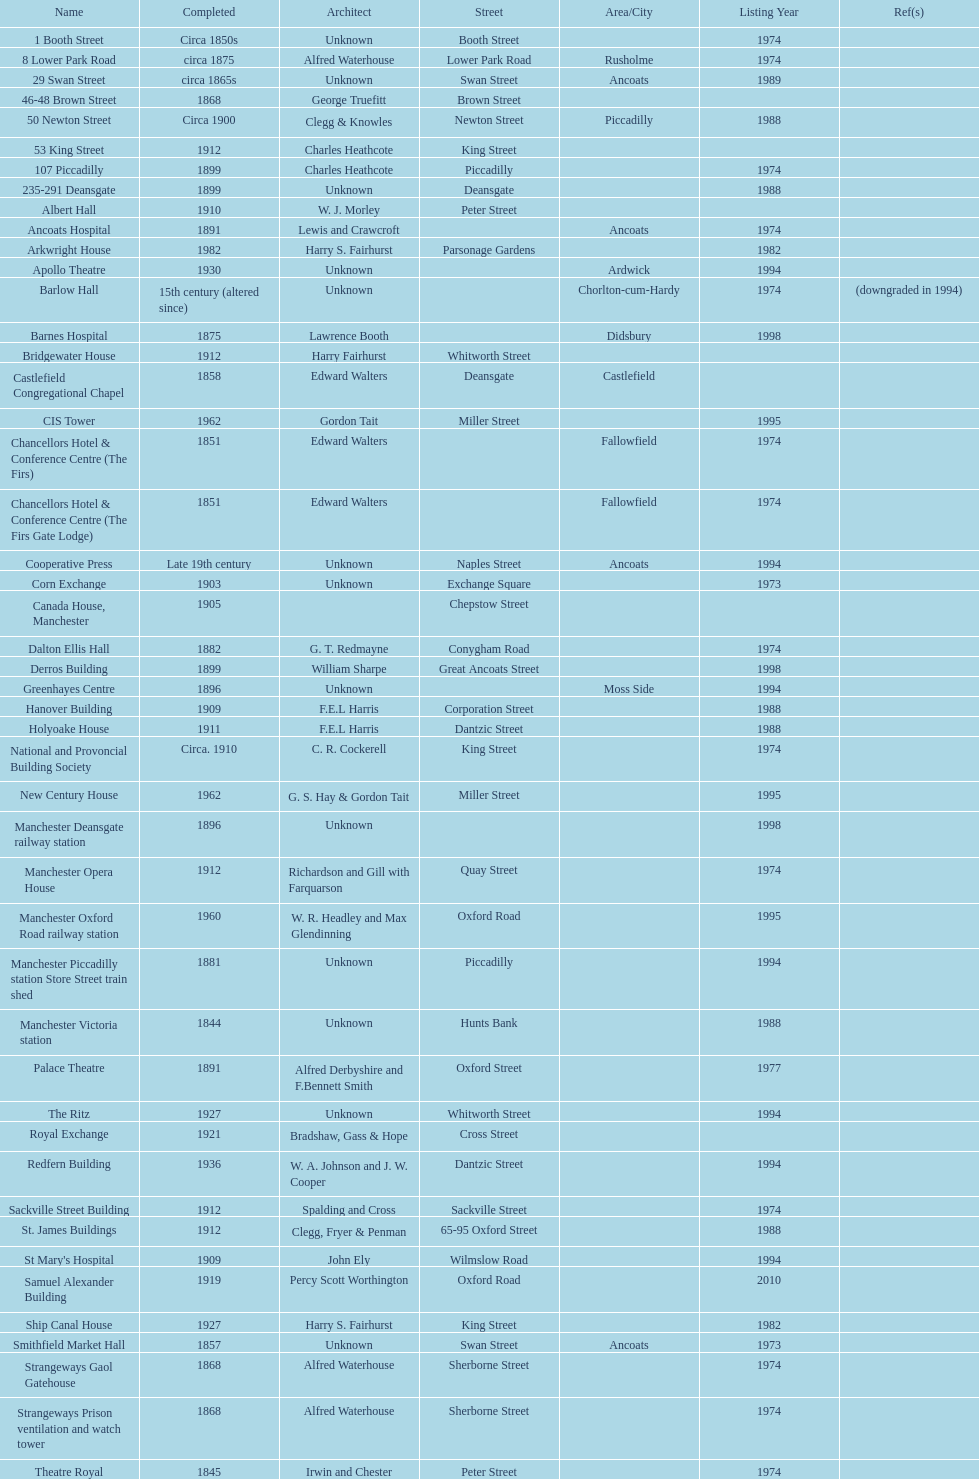How many buildings do not have an image listed? 11. 